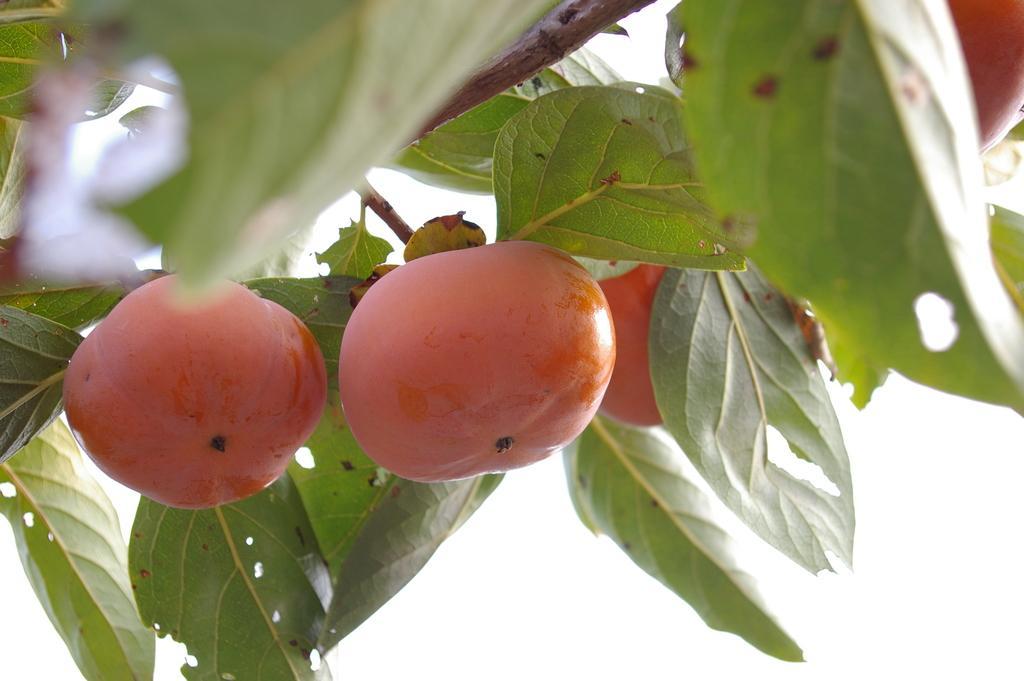Describe this image in one or two sentences. In this image I can see few fruits in red color and leaves in green color and I can see white color background. 